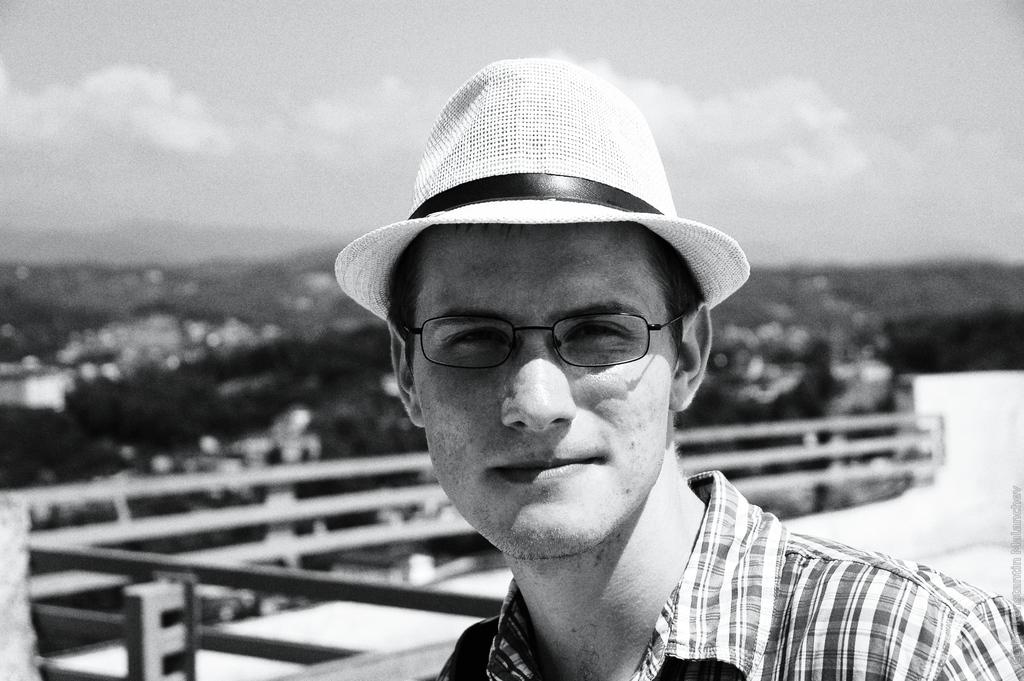What is the main subject of the image? The main subject of the image is a man. What accessories is the man wearing in the image? The man is wearing spectacles and a cap in the image. How would you describe the background of the image? The background of the image is blurry. What is the color scheme of the image? The image is black and white. What type of apple is the man holding in the image? There is no apple present in the image; the man is not holding any object. What legal advice is the man seeking in the image? There is no indication of the man seeking legal advice or being a lawyer in the image. 